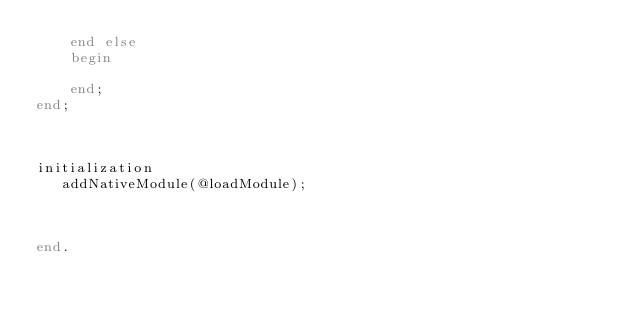Convert code to text. <code><loc_0><loc_0><loc_500><loc_500><_Pascal_>    end else
    begin

    end;
end;



initialization
   addNativeModule(@loadModule);



end.
</code> 